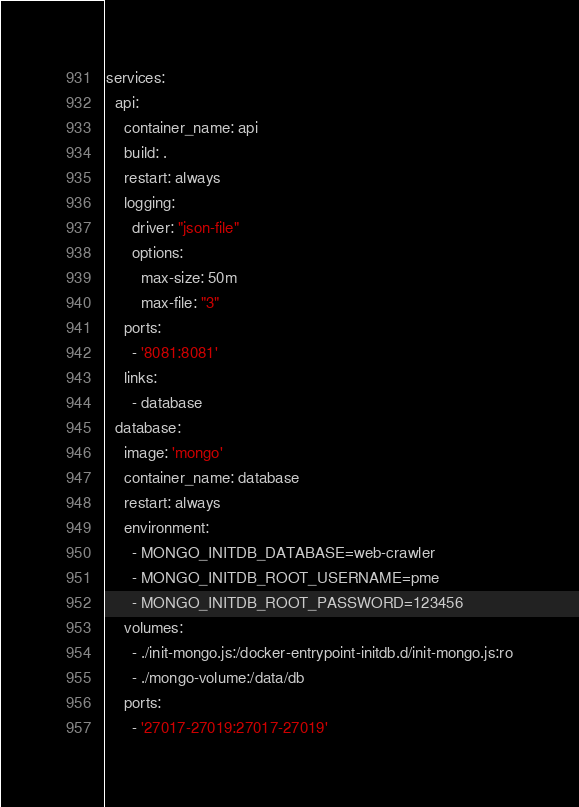<code> <loc_0><loc_0><loc_500><loc_500><_YAML_>services:
  api:
    container_name: api
    build: .
    restart: always
    logging:
      driver: "json-file"
      options:
        max-size: 50m
        max-file: "3"
    ports:
      - '8081:8081'
    links:
      - database
  database:
    image: 'mongo'
    container_name: database
    restart: always
    environment:
      - MONGO_INITDB_DATABASE=web-crawler
      - MONGO_INITDB_ROOT_USERNAME=pme
      - MONGO_INITDB_ROOT_PASSWORD=123456
    volumes:
      - ./init-mongo.js:/docker-entrypoint-initdb.d/init-mongo.js:ro
      - ./mongo-volume:/data/db
    ports:
      - '27017-27019:27017-27019'</code> 